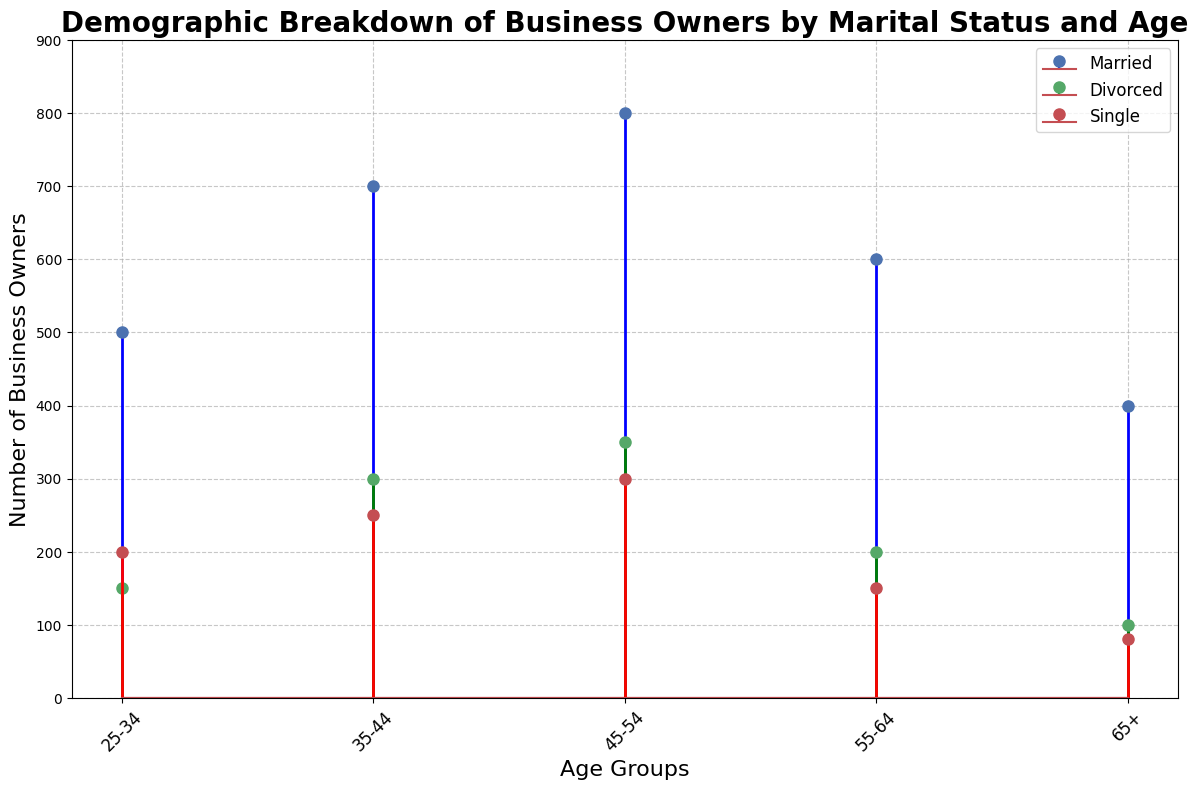Which age group has the highest number of married business owners? By examining the figure, look for the bar or stem line with the greatest height among the blue lines, which represent married business owners. In this case, the age group 45-54 has the highest number of married business owners at 800.
Answer: 45-54 How does the number of divorced business owners in the 35-44 age group compare to the number of single business owners in the 45-54 age group? Locate the green line (divorced) for the 35-44 age group and the red line (single) for the 45-54 age group. The number of divorced business owners in the 35-44 age group is 300, while the number of single business owners in the 45-54 age group is 300. They are equal.
Answer: Equal What is the sum of married, divorced, and single business owners in the 25-34 age group? Add up the numbers for married (500), divorced (150), and single (200) business owners in the 25-34 age group. The sum is 500 + 150 + 200 = 850.
Answer: 850 Is the number of divorced business owners greater than single business owners in the 55-64 age group? Compare the height of the green line (divorced) and the red line (single) in the 55-64 age group. The number of divorced business owners is 200, while the number of single business owners is 150. So, yes, the number of divorced business owners is greater.
Answer: Yes What is the average number of business owners (married, divorced, single) in the 45-54 age group? Sum the number of business owners in the 45-54 age group: married (800), divorced (350), and single (300). Divide the total by 3 to get the average. (800 + 350 + 300) / 3 = 1450 / 3 ≈ 483.33.
Answer: 483.33 Which marital status has the least number of business owners in the 65+ age group? Identify and compare the heights of the lines in the 65+ age group. The figures are married (400), divorced (100), and single (80). The marital status with the least number of business owners is single.
Answer: Single In which age group is the difference between married and divorced business owners the greatest? Calculate the difference between the number of married and divorced business owners for each age group. The differences are: 25-34: 500 - 150 = 350, 35-44: 700 - 300 = 400, 45-54: 800 - 350 = 450, 55-64: 600 - 200 = 400, 65+: 400 - 100 = 300. The greatest difference is in the 45-54 age group at 450.
Answer: 45-54 